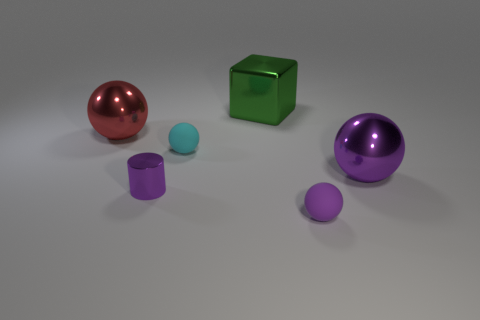Which objects in the picture seem reflective? The red and purple spheres as well as the green cube exhibit reflective surfaces that capture some of the ambient light and surrounding environment. 